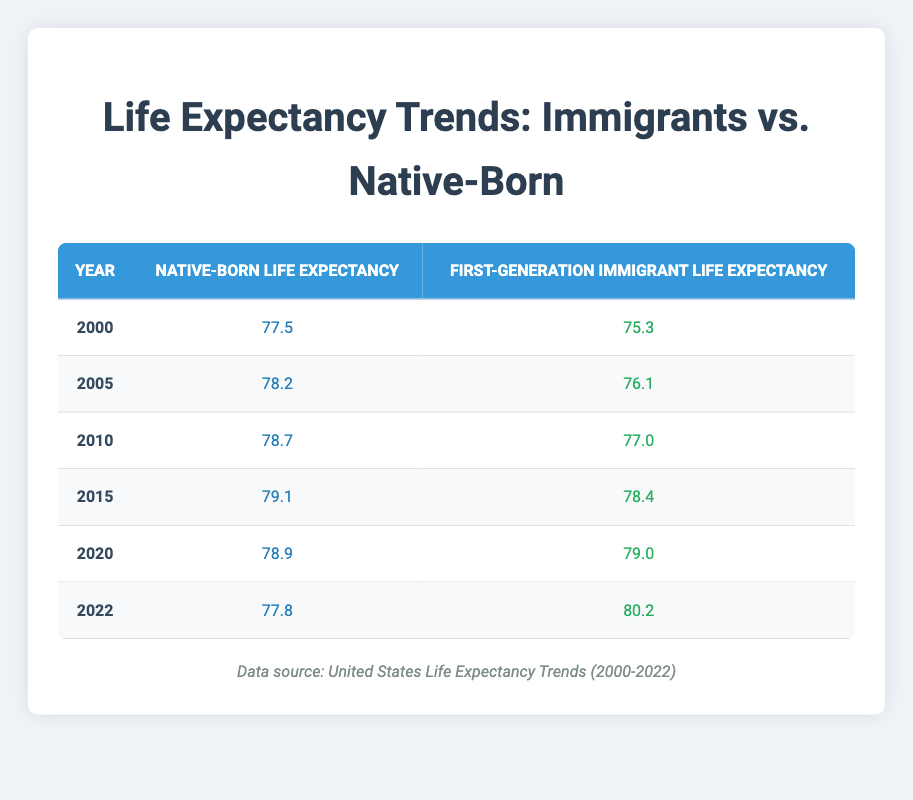What was the life expectancy for native-born citizens in 2020? In the table, I look at the row for the year 2020 under the "Native-Born Life Expectancy" column. The value listed there is 78.9.
Answer: 78.9 What was the life expectancy for first-generation immigrants in 2005? I find the row for the year 2005 and look under the "First-Generation Immigrant Life Expectancy" column. The value is 76.1.
Answer: 76.1 What is the difference in life expectancy for first-generation immigrants between 2010 and 2015? First, I find the life expectancy for first-generation immigrants in 2010, which is 77.0. Next, I find it for 2015, which is 78.4. The difference is 78.4 - 77.0 = 1.4.
Answer: 1.4 Did the life expectancy for first-generation immigrants increase from 2015 to 2020? Looking at the life expectancy for first-generation immigrants in 2015, it was 78.4, and in 2020, it was 79.0. Since 79.0 is greater than 78.4, it confirms the increase.
Answer: Yes What was the life expectancy of native-born citizens in the year with the highest value over the two decades? I review the table for the highest value in the "Native-Born Life Expectancy" column. The highest value is 79.1 in the year 2015.
Answer: 79.1 What was the average life expectancy for first-generation immigrants from 2000 to 2022? I add the life expectancy values for first-generation immigrants from each year (75.3 + 76.1 + 77.0 + 78.4 + 79.0 + 80.2 = 466.0) and then divide by the number of years (6) to find the average: 466.0 / 6 = 77.6667.
Answer: 77.67 Between which years did first-generation immigrants experience the largest increase in life expectancy? To find the largest increase, I compare the values year by year for first-generation immigrants: (75.3 to 76.1 = 0.8), (76.1 to 77.0 = 0.9), (77.0 to 78.4 = 1.4), (78.4 to 79.0 = 0.6), (79.0 to 80.2 = 1.2). The largest increase was from 2010 to 2015 at 1.4.
Answer: 2010 to 2015 